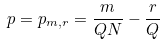<formula> <loc_0><loc_0><loc_500><loc_500>p = p _ { m , r } = \frac { m } { Q N } - \frac { r } { Q }</formula> 